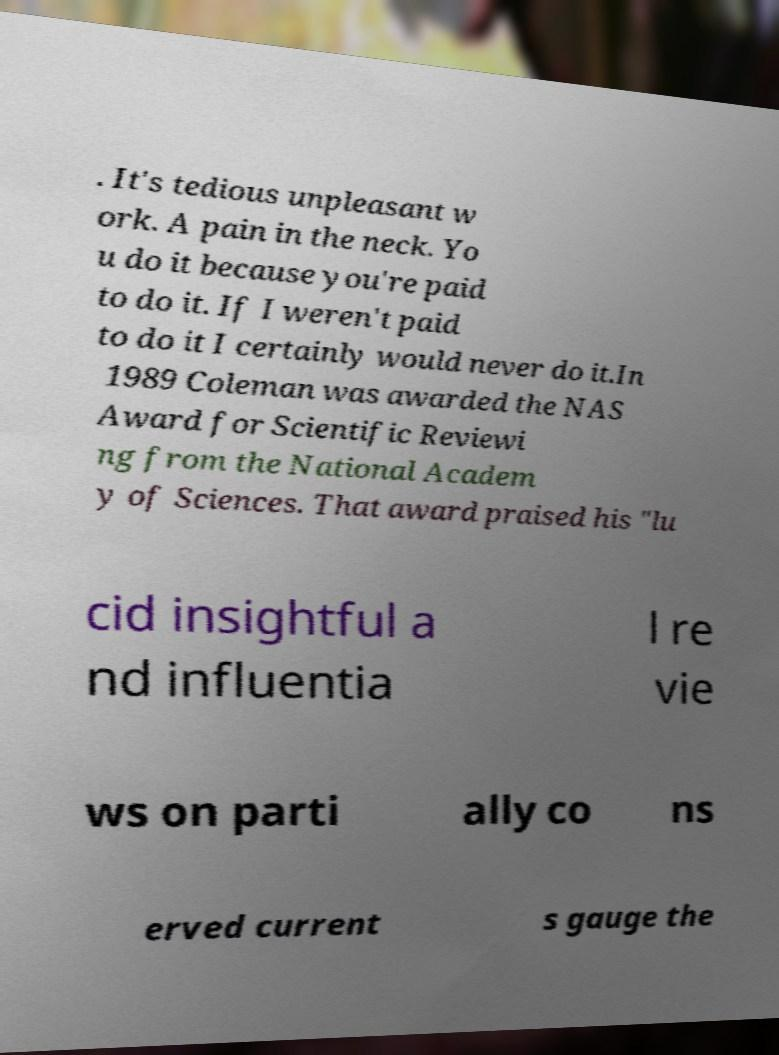I need the written content from this picture converted into text. Can you do that? . It's tedious unpleasant w ork. A pain in the neck. Yo u do it because you're paid to do it. If I weren't paid to do it I certainly would never do it.In 1989 Coleman was awarded the NAS Award for Scientific Reviewi ng from the National Academ y of Sciences. That award praised his "lu cid insightful a nd influentia l re vie ws on parti ally co ns erved current s gauge the 